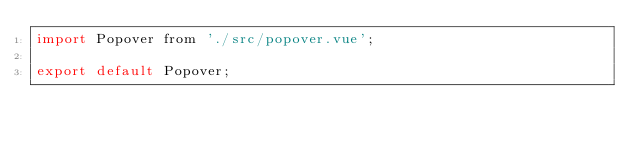Convert code to text. <code><loc_0><loc_0><loc_500><loc_500><_JavaScript_>import Popover from './src/popover.vue';

export default Popover;</code> 